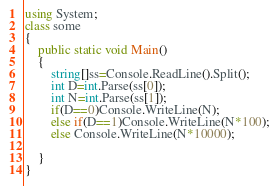<code> <loc_0><loc_0><loc_500><loc_500><_C#_>using System;
class some
{
	public static void Main()
	{
		string[]ss=Console.ReadLine().Split();
		int D=int.Parse(ss[0]);
		int N=int.Parse(ss[1]);
		if(D==0)Console.WriteLine(N);
		else if(D==1)Console.WriteLine(N*100);
		else Console.WriteLine(N*10000);
		
	}
}
</code> 